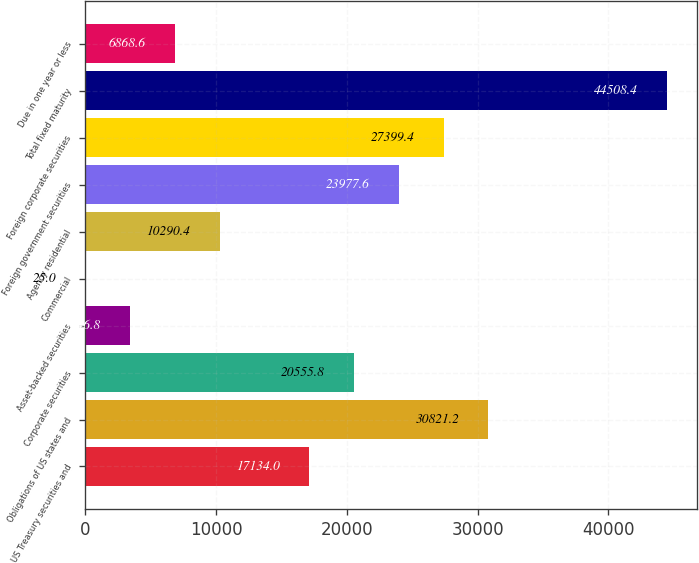Convert chart to OTSL. <chart><loc_0><loc_0><loc_500><loc_500><bar_chart><fcel>US Treasury securities and<fcel>Obligations of US states and<fcel>Corporate securities<fcel>Asset-backed securities<fcel>Commercial<fcel>Agency residential<fcel>Foreign government securities<fcel>Foreign corporate securities<fcel>Total fixed maturity<fcel>Due in one year or less<nl><fcel>17134<fcel>30821.2<fcel>20555.8<fcel>3446.8<fcel>25<fcel>10290.4<fcel>23977.6<fcel>27399.4<fcel>44508.4<fcel>6868.6<nl></chart> 